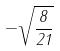Convert formula to latex. <formula><loc_0><loc_0><loc_500><loc_500>- \sqrt { \frac { 8 } { 2 1 } }</formula> 